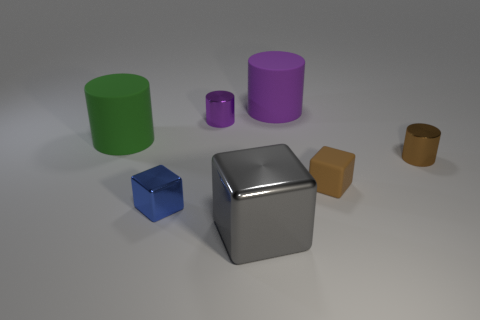Do the tiny metallic cube and the tiny matte thing have the same color?
Offer a terse response. No. What shape is the small blue thing?
Ensure brevity in your answer.  Cube. Is the number of green rubber cylinders that are on the left side of the blue thing greater than the number of large shiny cubes that are behind the brown cube?
Provide a short and direct response. Yes. Do the large matte thing that is on the left side of the blue metal cube and the big object on the right side of the gray metallic block have the same shape?
Ensure brevity in your answer.  Yes. How many other objects are the same size as the gray cube?
Provide a short and direct response. 2. How big is the brown metallic thing?
Provide a short and direct response. Small. Do the large block right of the purple metallic thing and the small purple object have the same material?
Offer a terse response. Yes. What color is the other tiny rubber object that is the same shape as the tiny blue object?
Provide a succinct answer. Brown. There is a large object that is in front of the tiny brown matte cube; does it have the same color as the tiny matte thing?
Provide a succinct answer. No. Are there any brown shiny things left of the large purple rubber thing?
Make the answer very short. No. 